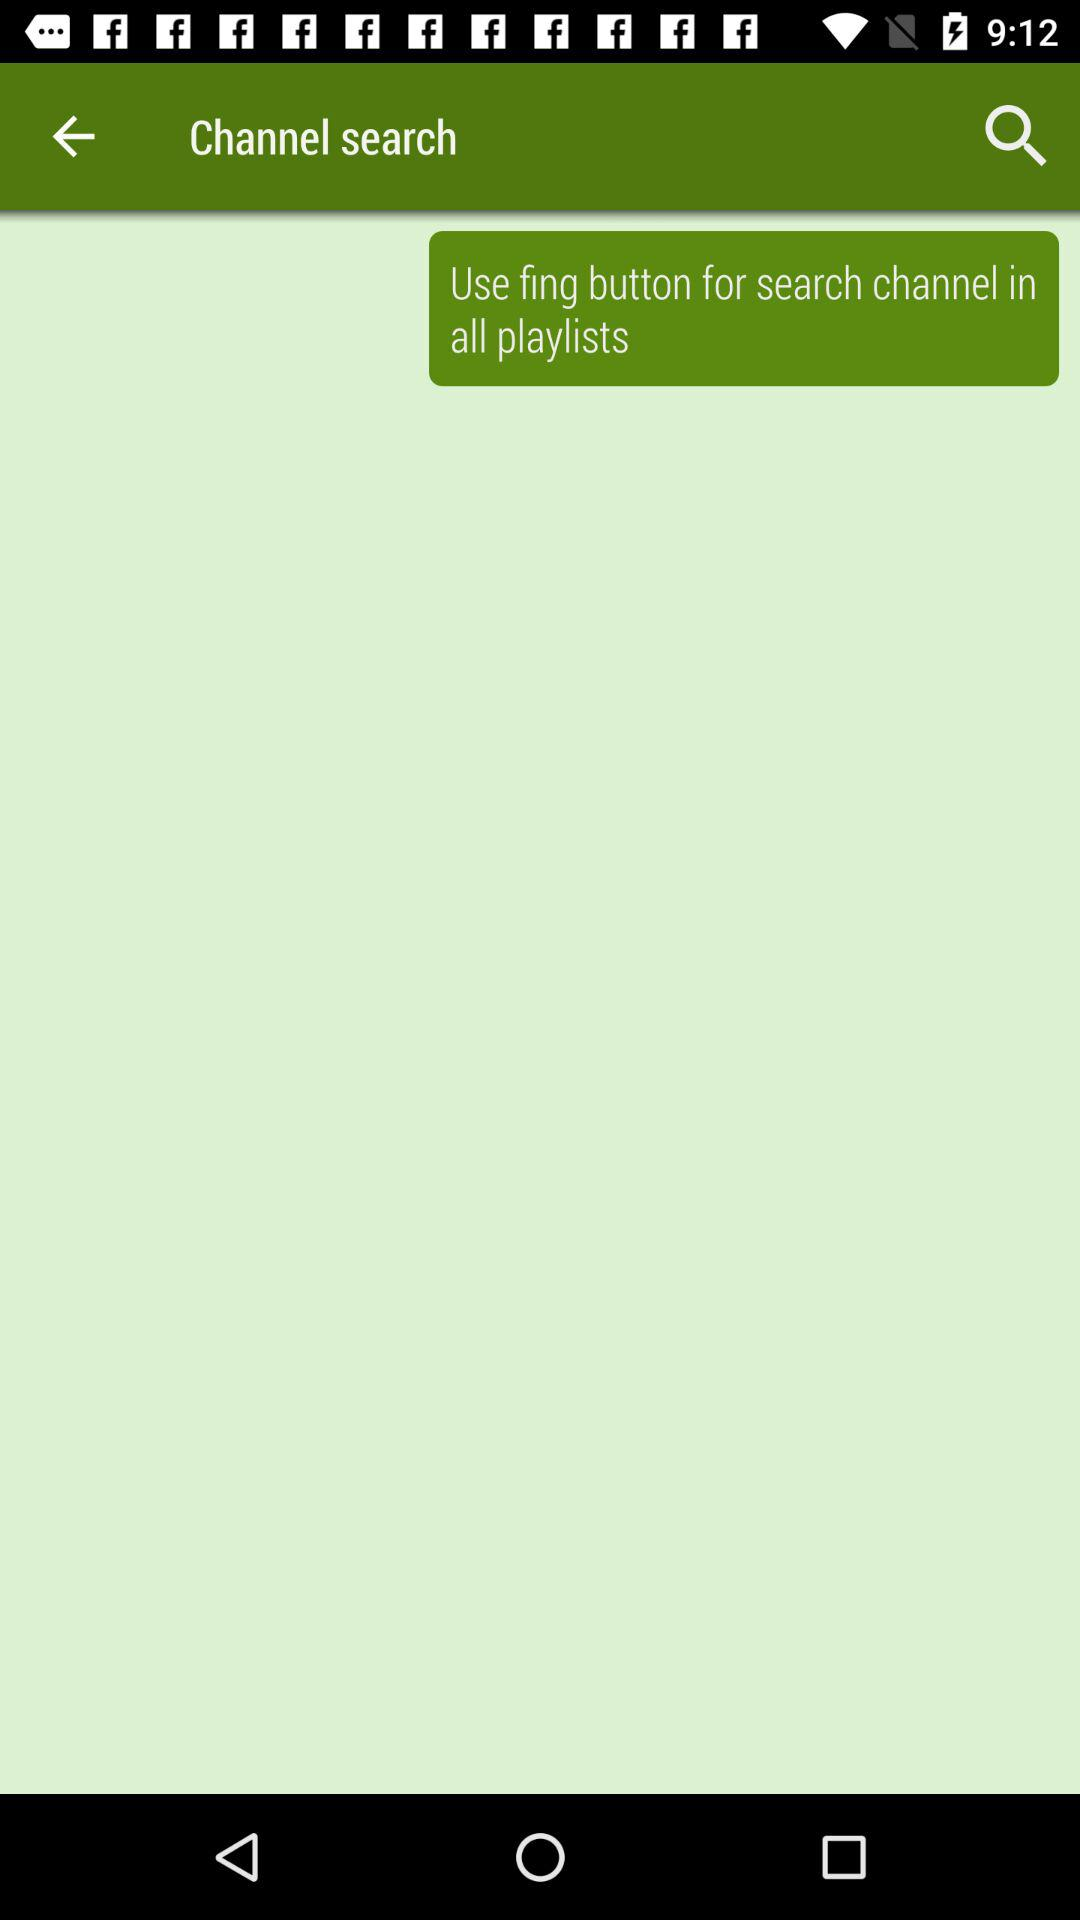What button can be used to search channels in all playlists? The button that can be used to search channels in all playlists is "fing". 